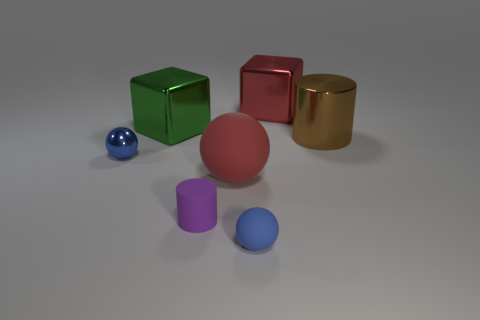How would the scene change if the light source were different? A change in the light source could dramatically alter the appearance of the scene. If the light were warmer or cooler in color, the hues of the objects would shift accordingly. A dimmer light source would soften the shadows and reduce reflections, while a brighter one could increase contrast and highlight textures. 